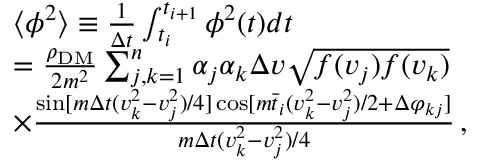<formula> <loc_0><loc_0><loc_500><loc_500>\begin{array} { r l } & { \langle \phi ^ { 2 } \rangle \equiv \frac { 1 } \Delta t } \int _ { t _ { i } } ^ { t _ { i + 1 } } \phi ^ { 2 } ( t ) d t } \\ & { = \frac { \rho _ { D M } } { 2 m ^ { 2 } } \sum _ { j , k = 1 } ^ { n } \alpha _ { j } \alpha _ { k } \Delta v \sqrt { f ( v _ { j } ) f ( v _ { k } ) } } \\ & { \times \frac { \sin [ m \Delta t ( v _ { k } ^ { 2 } - v _ { j } ^ { 2 } ) / 4 ] \cos [ m \bar { t } _ { i } ( v _ { k } ^ { 2 } - v _ { j } ^ { 2 } ) / 2 + \Delta \varphi _ { k j } ] } { m \Delta t ( v _ { k } ^ { 2 } - v _ { j } ^ { 2 } ) / 4 } \, , } \end{array}</formula> 